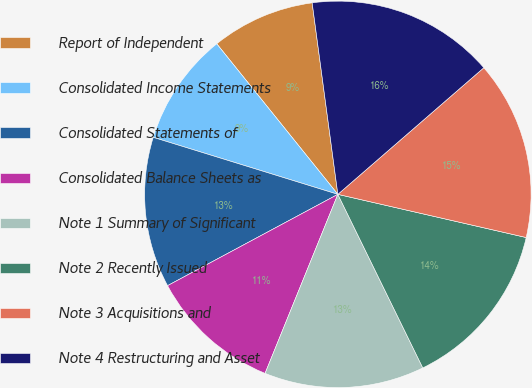<chart> <loc_0><loc_0><loc_500><loc_500><pie_chart><fcel>Report of Independent<fcel>Consolidated Income Statements<fcel>Consolidated Statements of<fcel>Consolidated Balance Sheets as<fcel>Note 1 Summary of Significant<fcel>Note 2 Recently Issued<fcel>Note 3 Acquisitions and<fcel>Note 4 Restructuring and Asset<nl><fcel>8.66%<fcel>9.45%<fcel>12.6%<fcel>11.02%<fcel>13.39%<fcel>14.17%<fcel>14.96%<fcel>15.75%<nl></chart> 